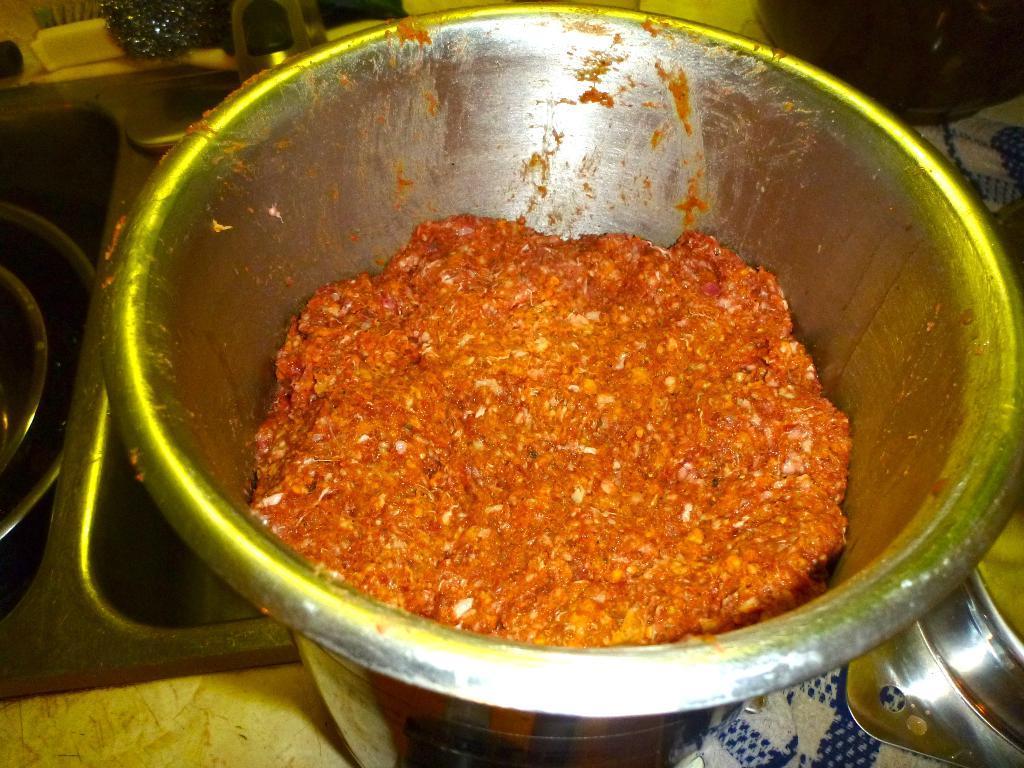Can you describe this image briefly? In this image there are objects on the surface, there is food inside a vessel, there are objects truncated towards the left of the image, there are objects truncated towards the right of the image, there are objects truncated towards the top of the image, there are objects truncated towards the bottom of the image. 